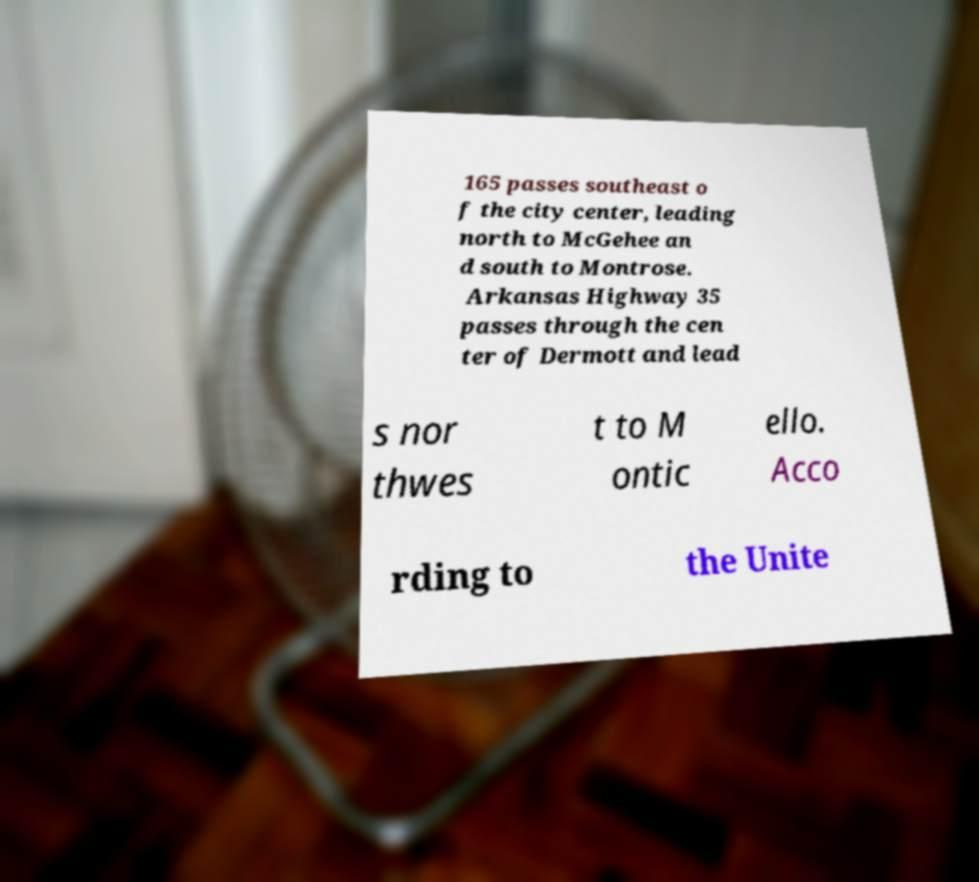Please identify and transcribe the text found in this image. 165 passes southeast o f the city center, leading north to McGehee an d south to Montrose. Arkansas Highway 35 passes through the cen ter of Dermott and lead s nor thwes t to M ontic ello. Acco rding to the Unite 